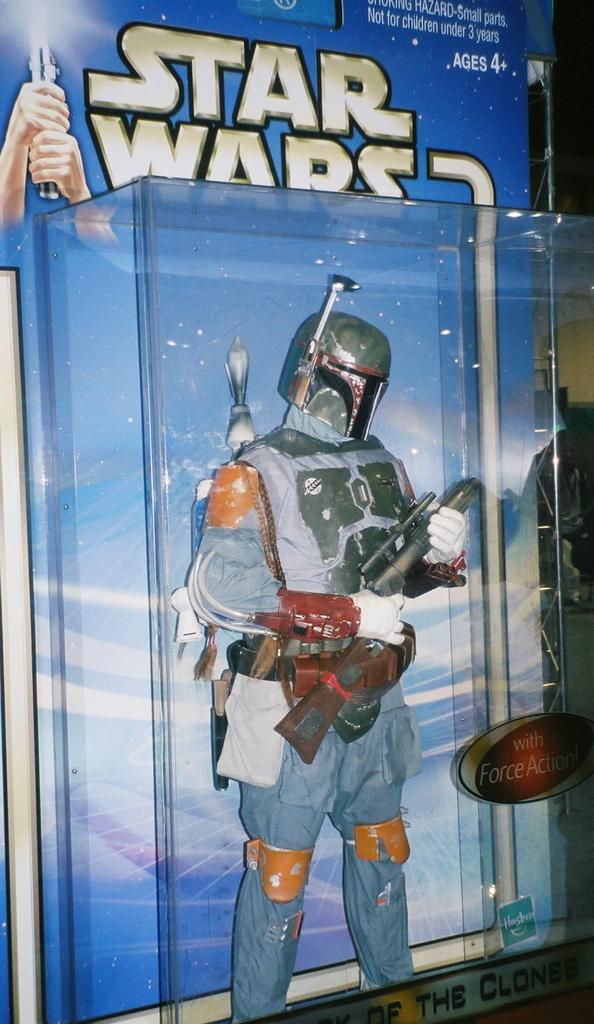<image>
Present a compact description of the photo's key features. a star wars action figure in bubble packaging 